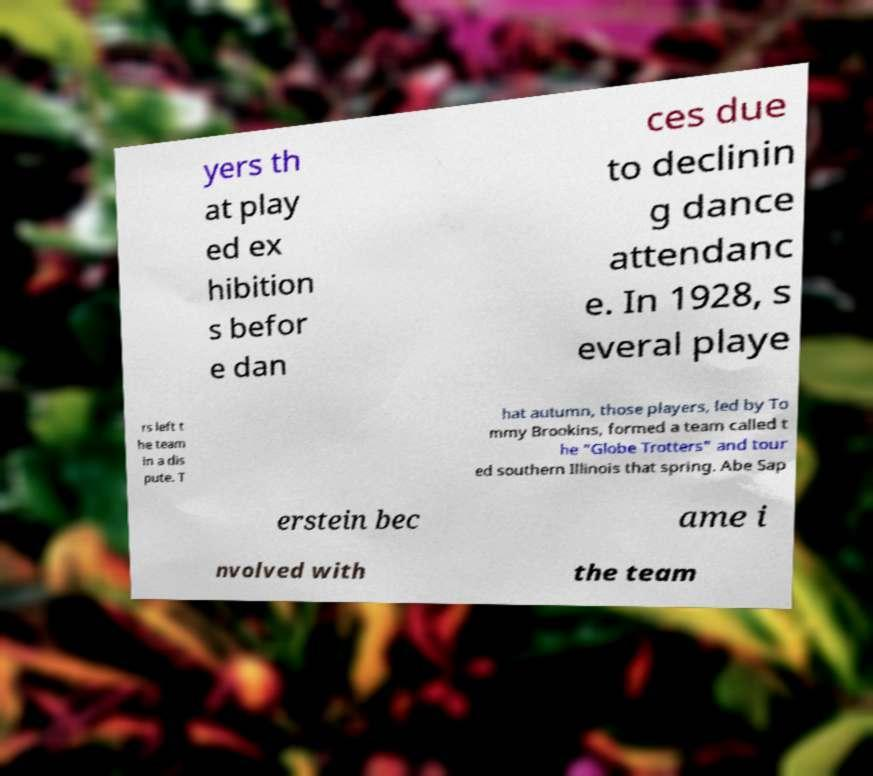There's text embedded in this image that I need extracted. Can you transcribe it verbatim? yers th at play ed ex hibition s befor e dan ces due to declinin g dance attendanc e. In 1928, s everal playe rs left t he team in a dis pute. T hat autumn, those players, led by To mmy Brookins, formed a team called t he "Globe Trotters" and tour ed southern Illinois that spring. Abe Sap erstein bec ame i nvolved with the team 